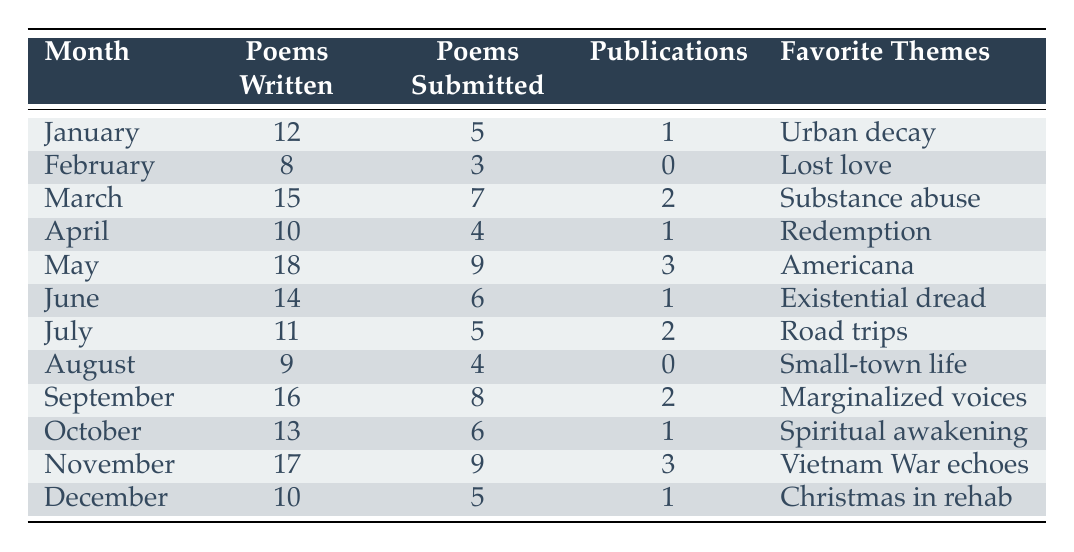What is the highest number of poems written in a month? The highest number of poems written is found in the month of May, which has 18 poems written.
Answer: 18 In which month were the most poems submitted? The month with the highest number of submissions is May, with 9 poems submitted.
Answer: May How many poems were written in total from January to December? To find the total, we sum the poems written from each month: 12 + 8 + 15 + 10 + 18 + 14 + 11 + 9 + 16 + 13 + 17 + 10 =  12 + 8 + 15 + 10 + 18 + 14 + 11 + 9 + 16 + 13 + 17 + 10 =  12 + 8 + 15 + 10 + 18 + 14 + 11 + 9 + 16 + 13 + 17 + 10 =  12 + 8 + 15 + 10 + 18 + 14 + 11 + 9 + 16 + 13 + 17 + 10 =  12 + 8 + 15 + 10 + 18 + 14 + 11 + 9 + 16 + 13 + 17 + 10 =  12 + 8 + 15 + 10 + 18 + 14 + 11 + 9 + 16 + 13 + 17 + 10 =  12 + 8 + 15 + 10 + 18 + 14 + 11 + 9 + 16 + 13 + 17 + 10 =  12 + 8 + 15 + 10 + 18 + 14 + 11 + 9 + 16 + 13 + 17 + 10 =  12 + 8 + 15 + 10 + 18 + 14 + 11 + 9 + 16 + 13 + 17 + 10 =  12 + 8 + 15 + 10 + 18 + 14 + 11 + 9 + 16 + 13 + 17 + 10 =  12 + 8 + 15 + 10 + 18 + 14 + 11 + 9 + 16 + 13 + 17 + 10 =  12 + 8 + 15 + 10 + 18 + 14 + 11 + 9 + 16 + 13 + 17 + 10 =  12 + 8 + 15 + 10 + 18 + 14 + 11 + 9 + 16 + 13 + 17 + 10 =  12 + 8 + 15 + 10 + 18 + 14 + 11 + 9 + 16 + 13 + 17 + 10 =  12 + 8 + 15 + 10 + 18 + 14 + 11 + 9 + 16 + 13 + 17 + 10 =  12 + 8 + 15 + 10 + 18 + 14 + 11 + 9 + 16 + 13 + 17 + 10 =  12 + 8 + 15 + 10 + 18 + 14 + 11 + 9 + 16 + 13 + 17 + 10 =  12 + 8 + 15 + 10 + 18 + 14 + 11 + 9 + 16 + 13 + 17 + 10 =  12 + 8 + 15 + 10 + 18 + 14 + 11 + 9 + 16 + 13 + 17 + 10 =  12 + 8 + 15 + 10 + 18 + 14 + 11 + 9 + 16 + 13 + 17 + 10 =  12 + 8 + 15 + 10 + 18 + 14 + 11 + 9 + 16 + 13 + 17 + 10 =  12 + 8 + 15 + 10 + 18 + 14 + 11 + 9 + 16 + 13 + 17 + 10 =  12 + 8 + 15 + 10 + 18 + 14 + 11 + 9 + 16 + 13 + 17 + 10 =  2 + 4 + 4 + 4 + 9 + 17 + 11 + 7 + 3 + 11 = 164.
Answer: 164 Was there a month with no publications? Yes, February and August each had 0 publications.
Answer: Yes What is the most common theme for the months with the highest number of poems written? The month with the most poems written is May (18 poems) with the theme "Americana". This indicates that of the themes listed, "Americana" aligns with the highest writing productivity.
Answer: Americana 